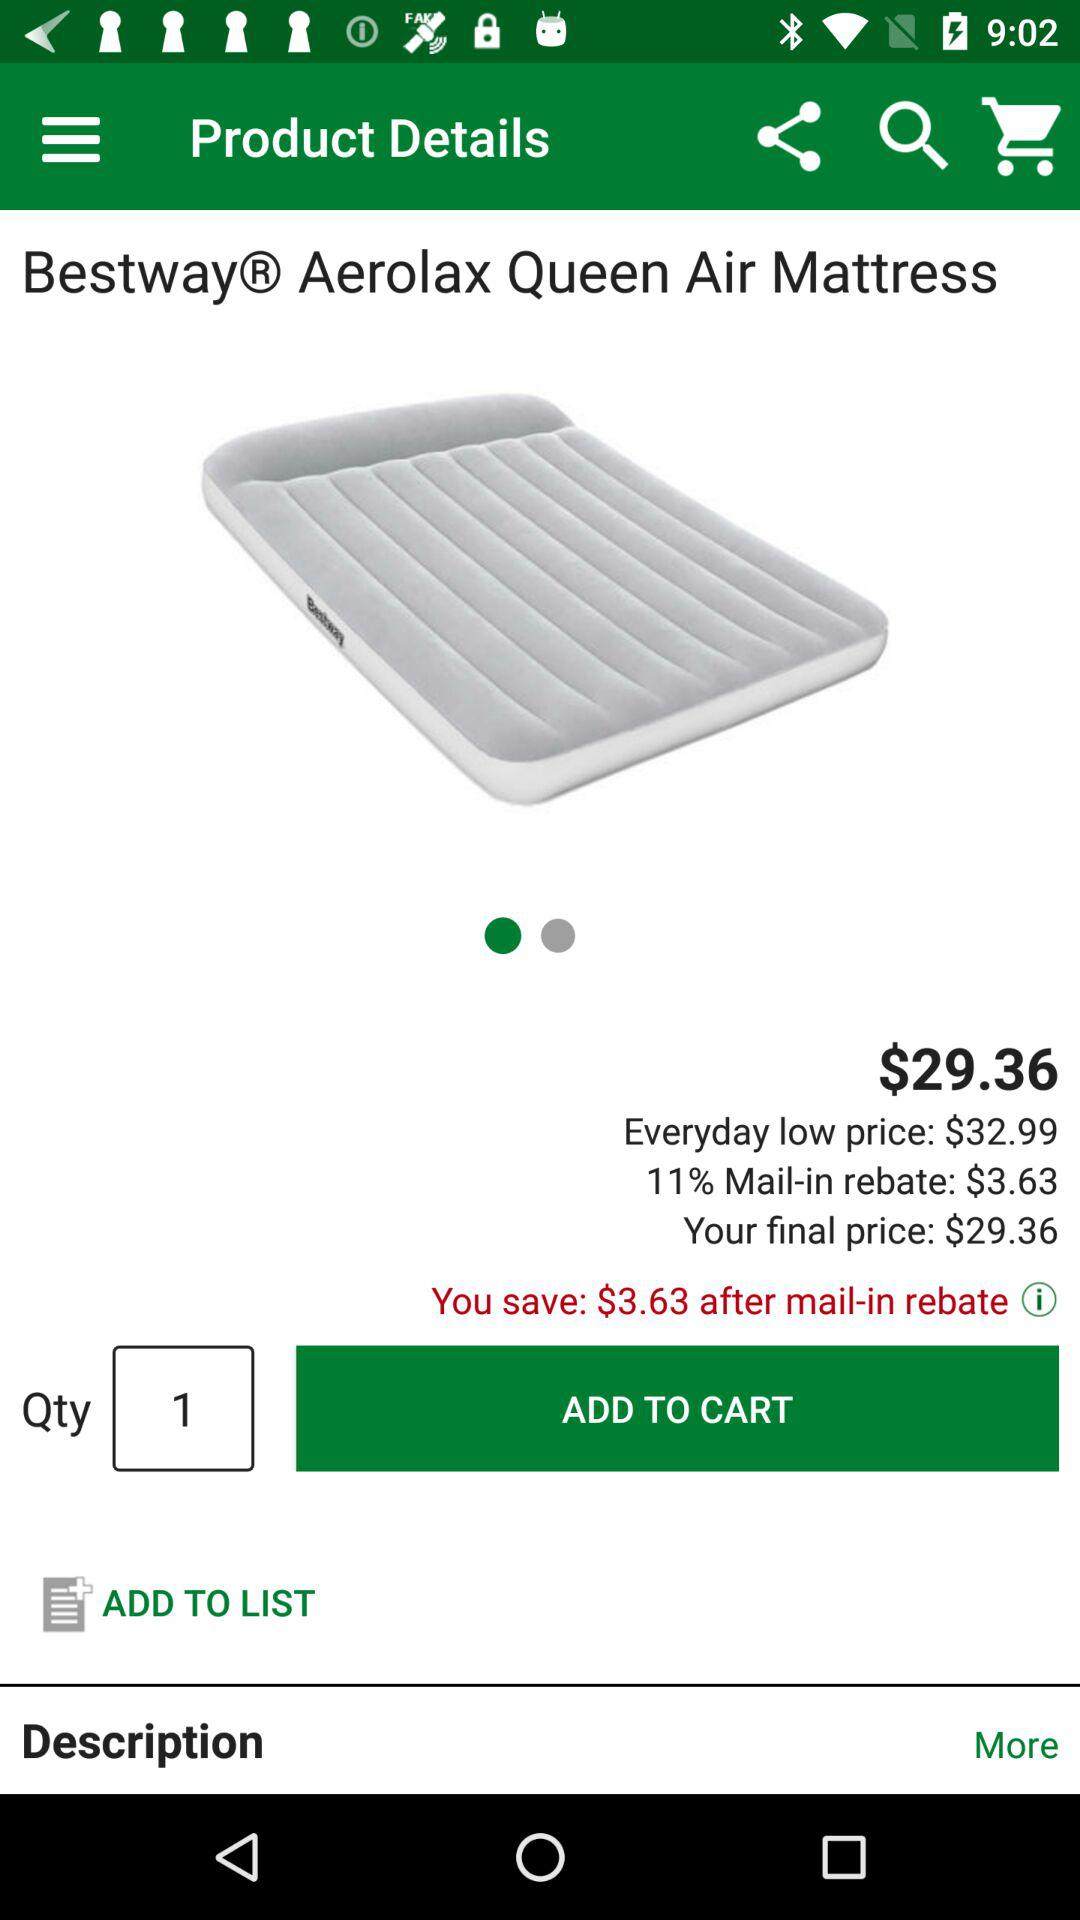What is the price of the item "Aerolax Queen Air Mattress"? The price of the item is $29.36. 